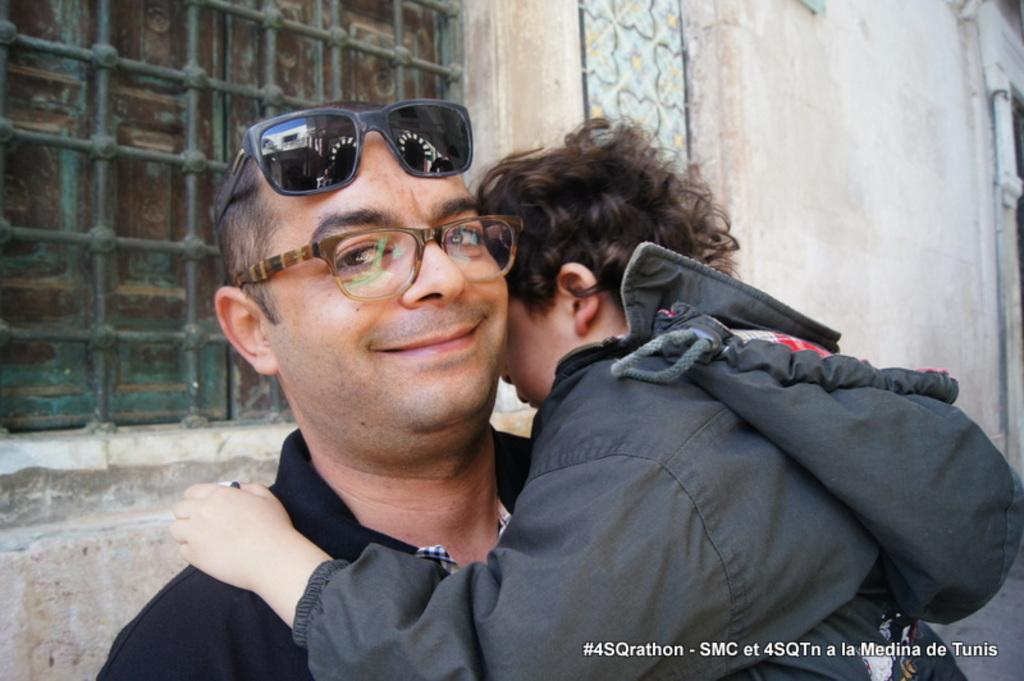How many people are in the image? There are two people in the image. What colors are the dresses worn by the people in the image? One person is wearing a black dress, and the other person is wearing a grey dress. What type of eyewear is worn by each person in the image? One person is wearing glasses, and the other person is wearing goggles. What can be seen in the background of the image? There is a window and a wall visible in the background of the image. What type of bed can be seen in the image? There is no bed present in the image. How much sugar is visible in the image? There is no sugar visible in the image. 